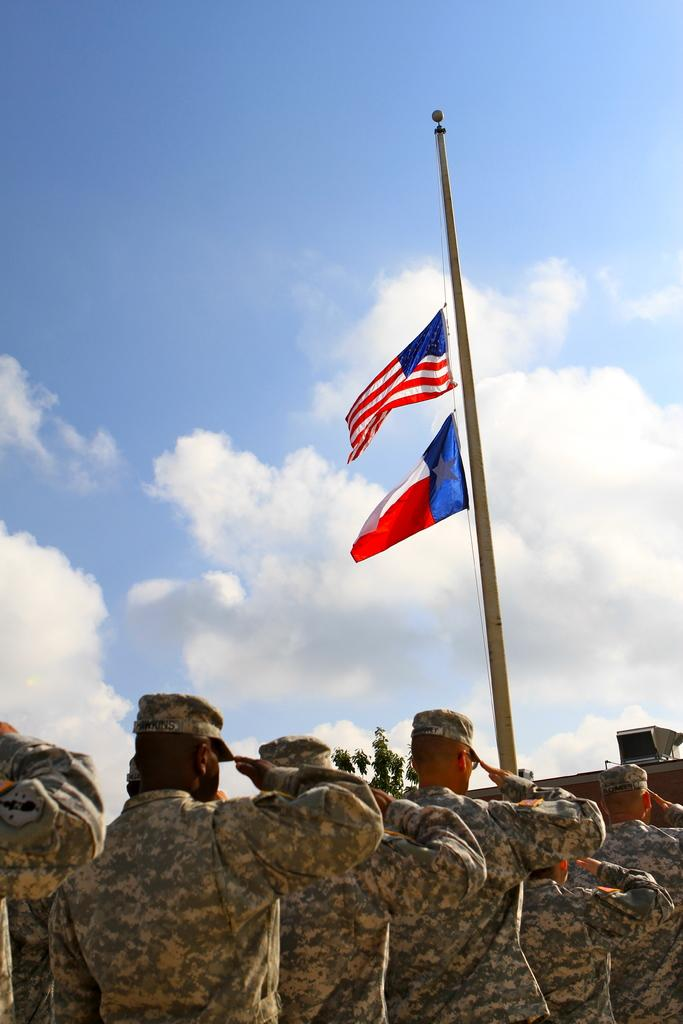What are the men in the image wearing? The men in the image are wearing army dress. What are the men doing in the image? The men are saluting in the image. What can be seen in the middle of the image? There are flags in the middle of the image. What is visible in the background of the image? The sky is visible in the image. What is the condition of the sky in the image? The sky is cloudy in the image. What type of hydrant is visible in the image? There is no hydrant present in the image. What kind of wine is being served to the men in the image? There is no wine present in the image; the men are in army dress and saluting. 